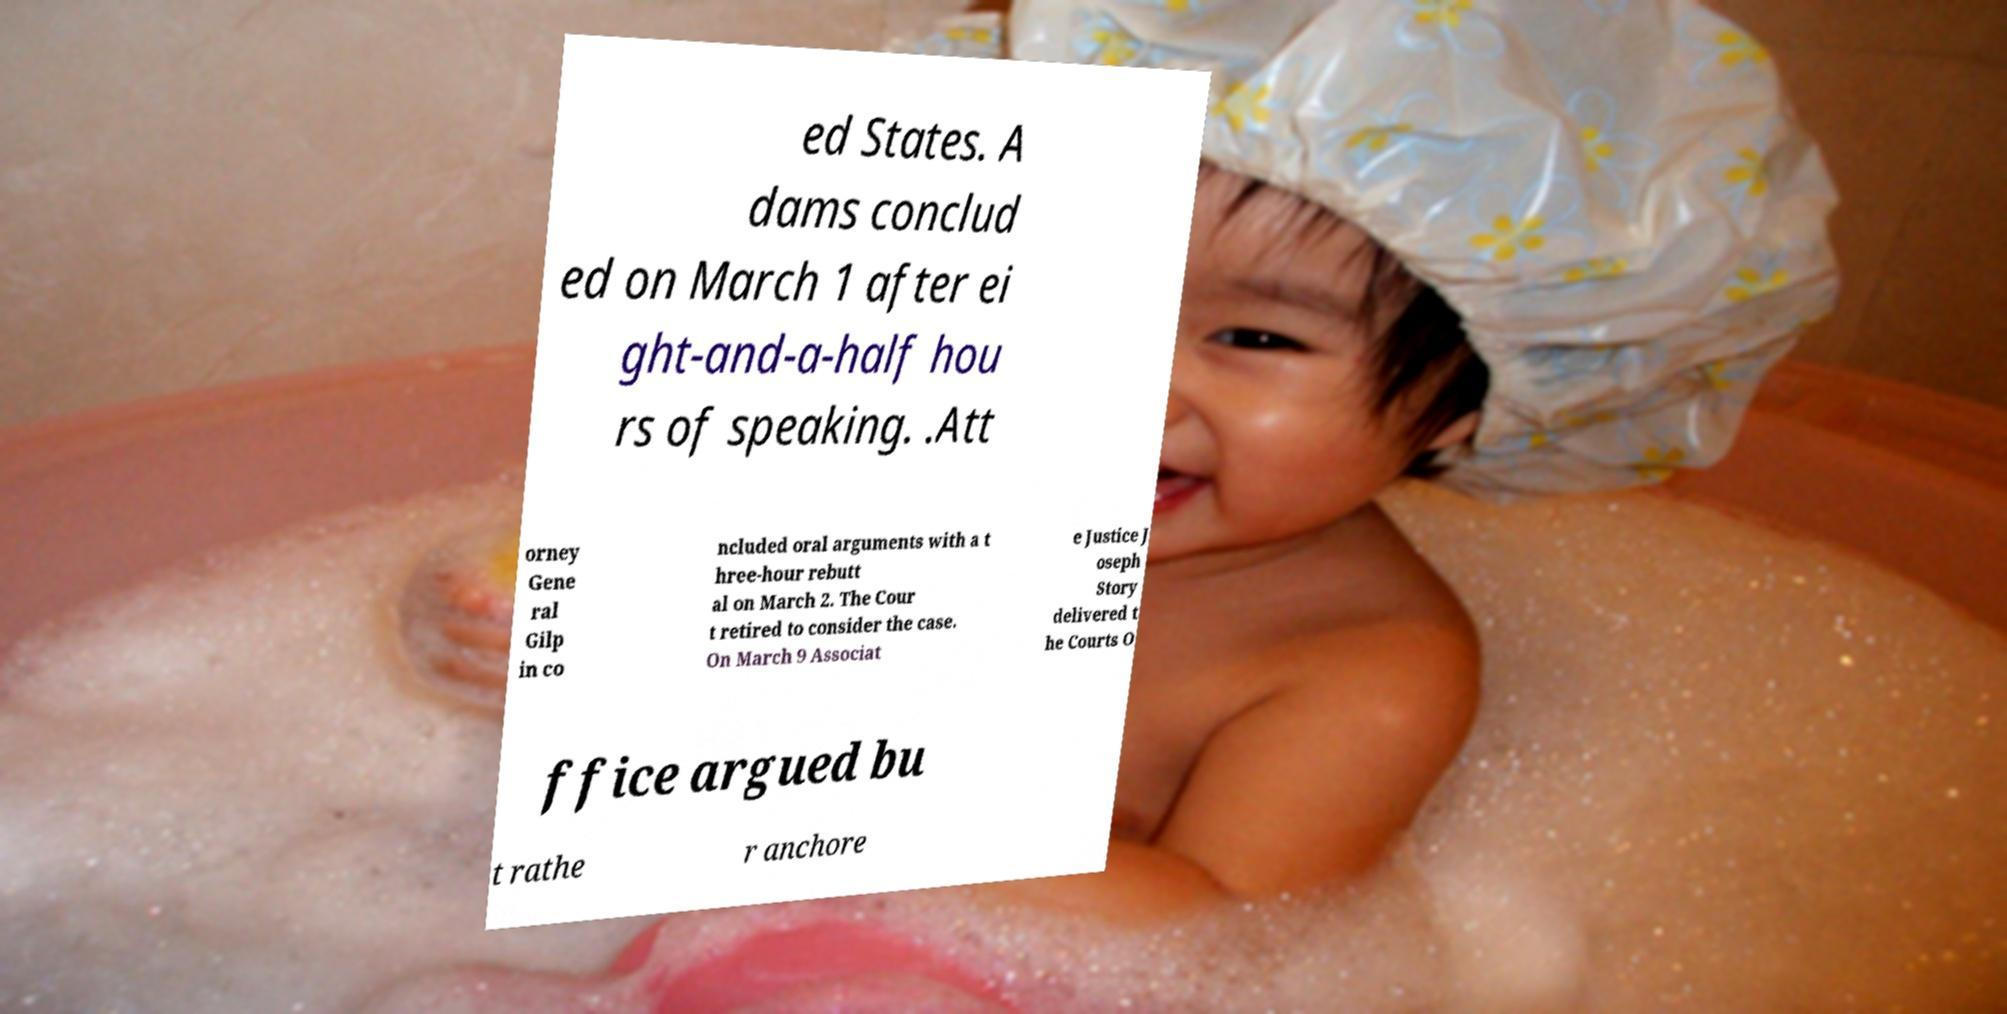There's text embedded in this image that I need extracted. Can you transcribe it verbatim? ed States. A dams conclud ed on March 1 after ei ght-and-a-half hou rs of speaking. .Att orney Gene ral Gilp in co ncluded oral arguments with a t hree-hour rebutt al on March 2. The Cour t retired to consider the case. On March 9 Associat e Justice J oseph Story delivered t he Courts O ffice argued bu t rathe r anchore 